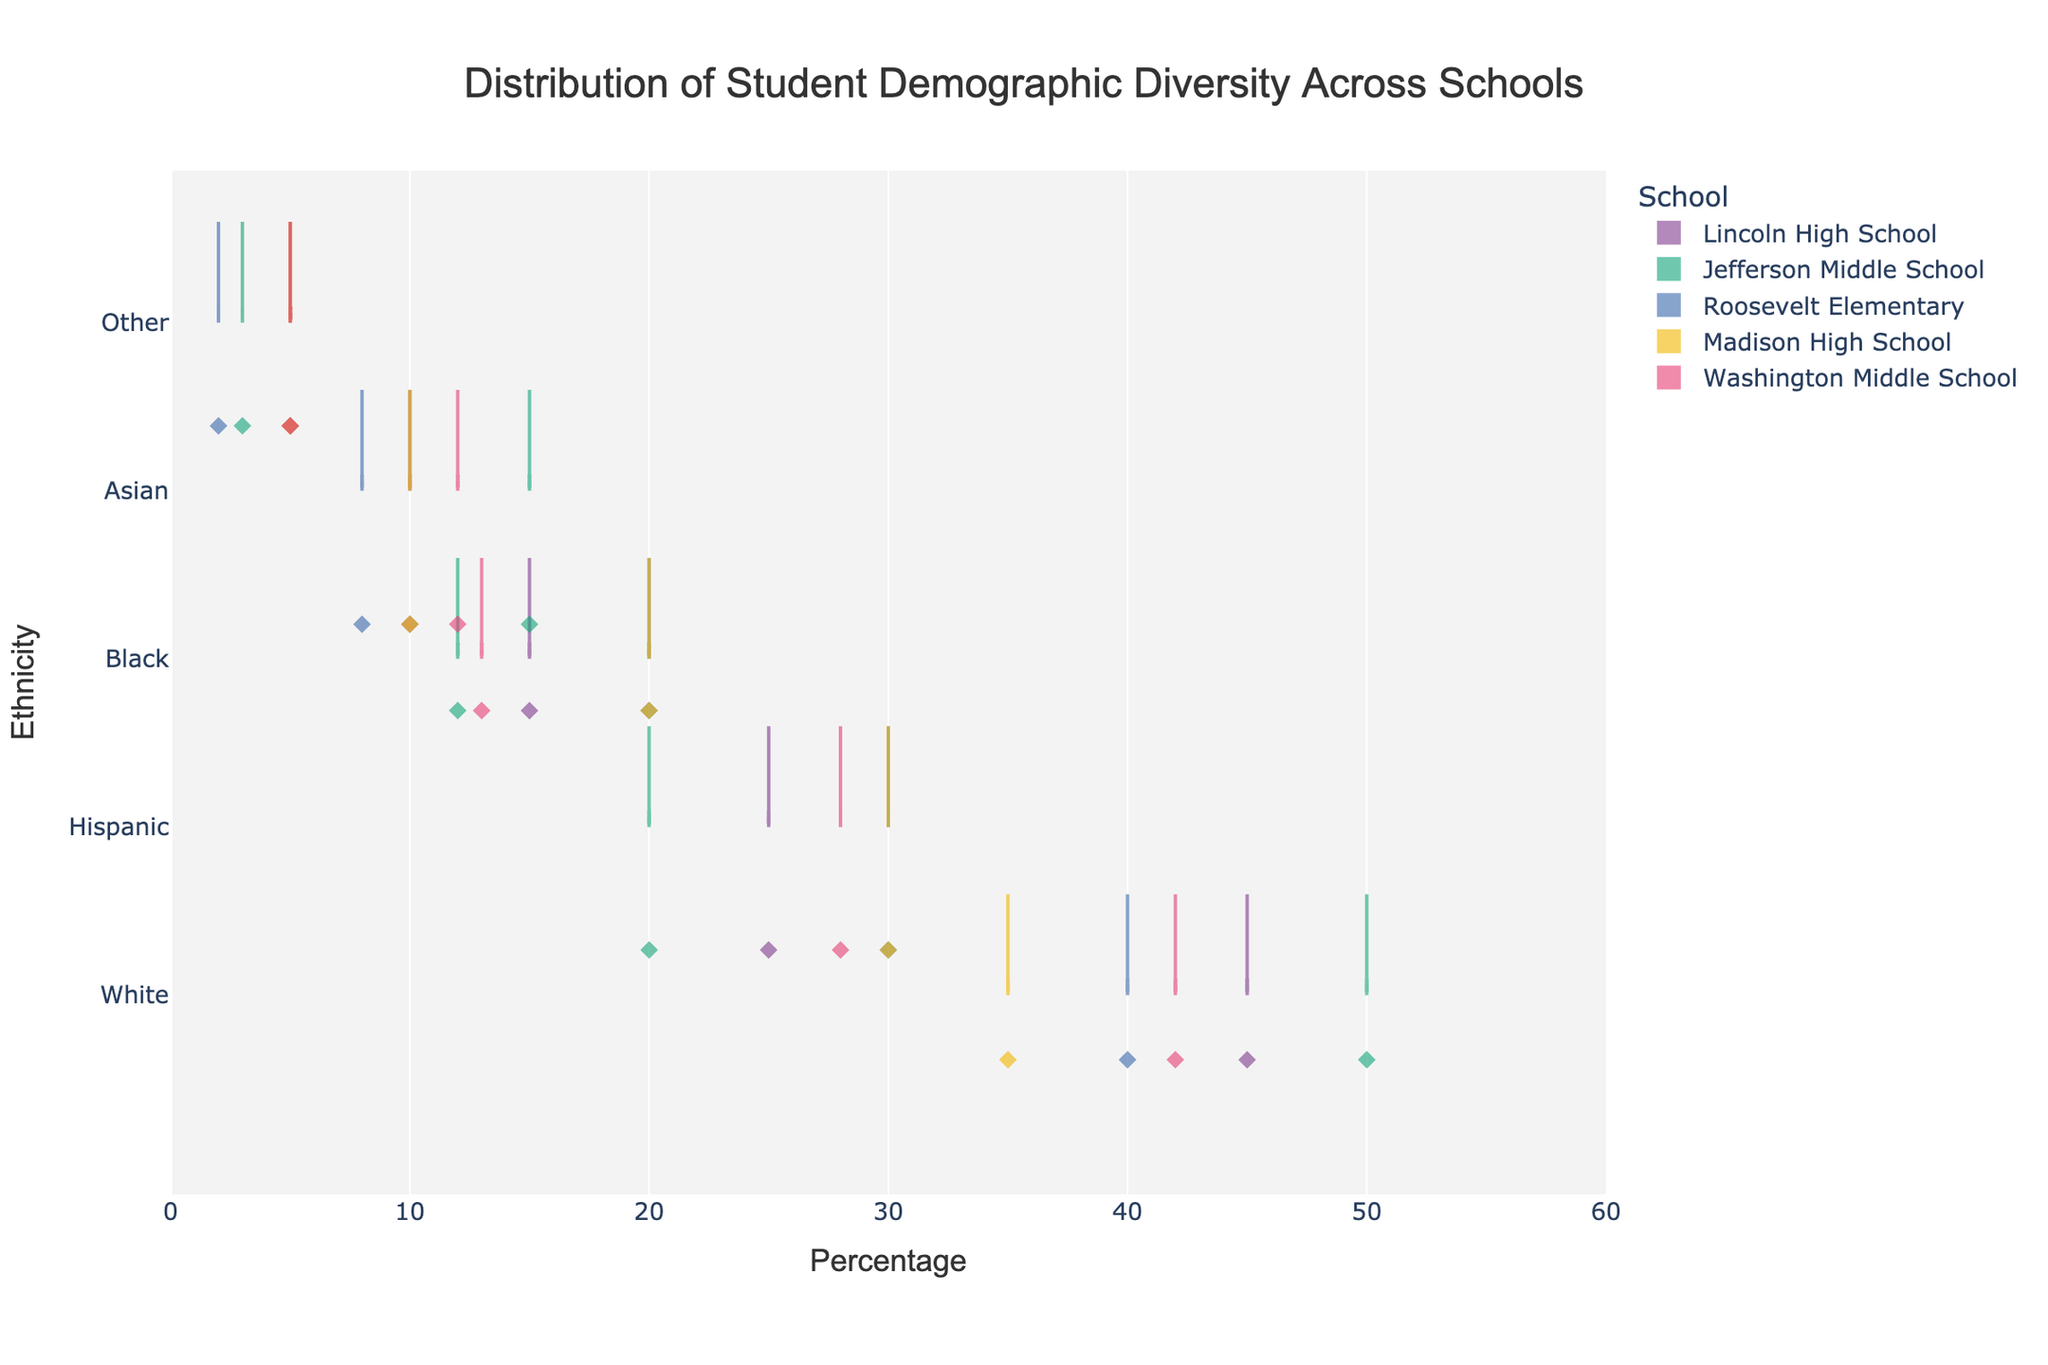What is the title of the chart? The title is positioned at the top center of the chart. It states the main focus of the visual, which usually describes the data being displayed.
Answer: Distribution of Student Demographic Diversity Across Schools What is the highest percentage of Hispanic students in the schools? Look at the x-axis, which represents the percentage. Identify the highest value for the Hispanic category across all the schools. The highest value for the Hispanic category is present at Roosevelt Elementary and Madison High School.
Answer: 30% How does the distribution of White students compare between Lincoln High School and Jefferson Middle School? Compare the width and spread of the violin plots for White students representing Lincoln High School and Jefferson Middle School. The percentages for the White category for Lincoln High School and Jefferson Middle School are 45% and 50% respectively.
Answer: Jefferson Middle School has a higher percentage of White students Which school has the most even distribution of ethnicities? Look at the width and spread of the violin plots for each school. The school with the percentages relatively closer to each other will have a more even distribution. Jefferson Middle School and Washington Middle School have the closer ranges of percentages across different ethnicities.
Answer: Washington Middle School Which ethnicity has the smallest representation across all schools? Observe the y-axis to identify each ethnicity, then look at the corresponding violin plots to determine which one has the smallest percentages across all schools. The 'Other' category consistently has the smallest percentages.
Answer: Other Compare the percentage of Black students in Roosevelt Elementary and Madison High School. Look at the violin plots for Black students for both Roosevelt Elementary and Madison High School to determine the percentages. Both schools show 20% for the Black category.
Answer: They have the same percentage What is the range of Asian student percentages across all schools? Identify the minimum and maximum percentages for the Asian category across all schools and calculate the range. All the percentages for the Asian category are 8%, 10%, 10%, 12%, and 15%. Therefore, the range is 15% - 8%.
Answer: 7% What does the box visible in each violin plot represent? The box within the violin plot indicates the interquartile range (IQR), showing the middle 50% of the data distribution. This measure is unique to violation plots, providing insight into data spread and central tendency.
Answer: Interquartile range Which school has the highest percentage of Black students? Identify the highest value for the Black category in the violin plots across all the schools. Roosevelt Elementary and Madison High School both have the highest percentage at 20%.
Answer: Roosevelt Elementary and Madison High School 